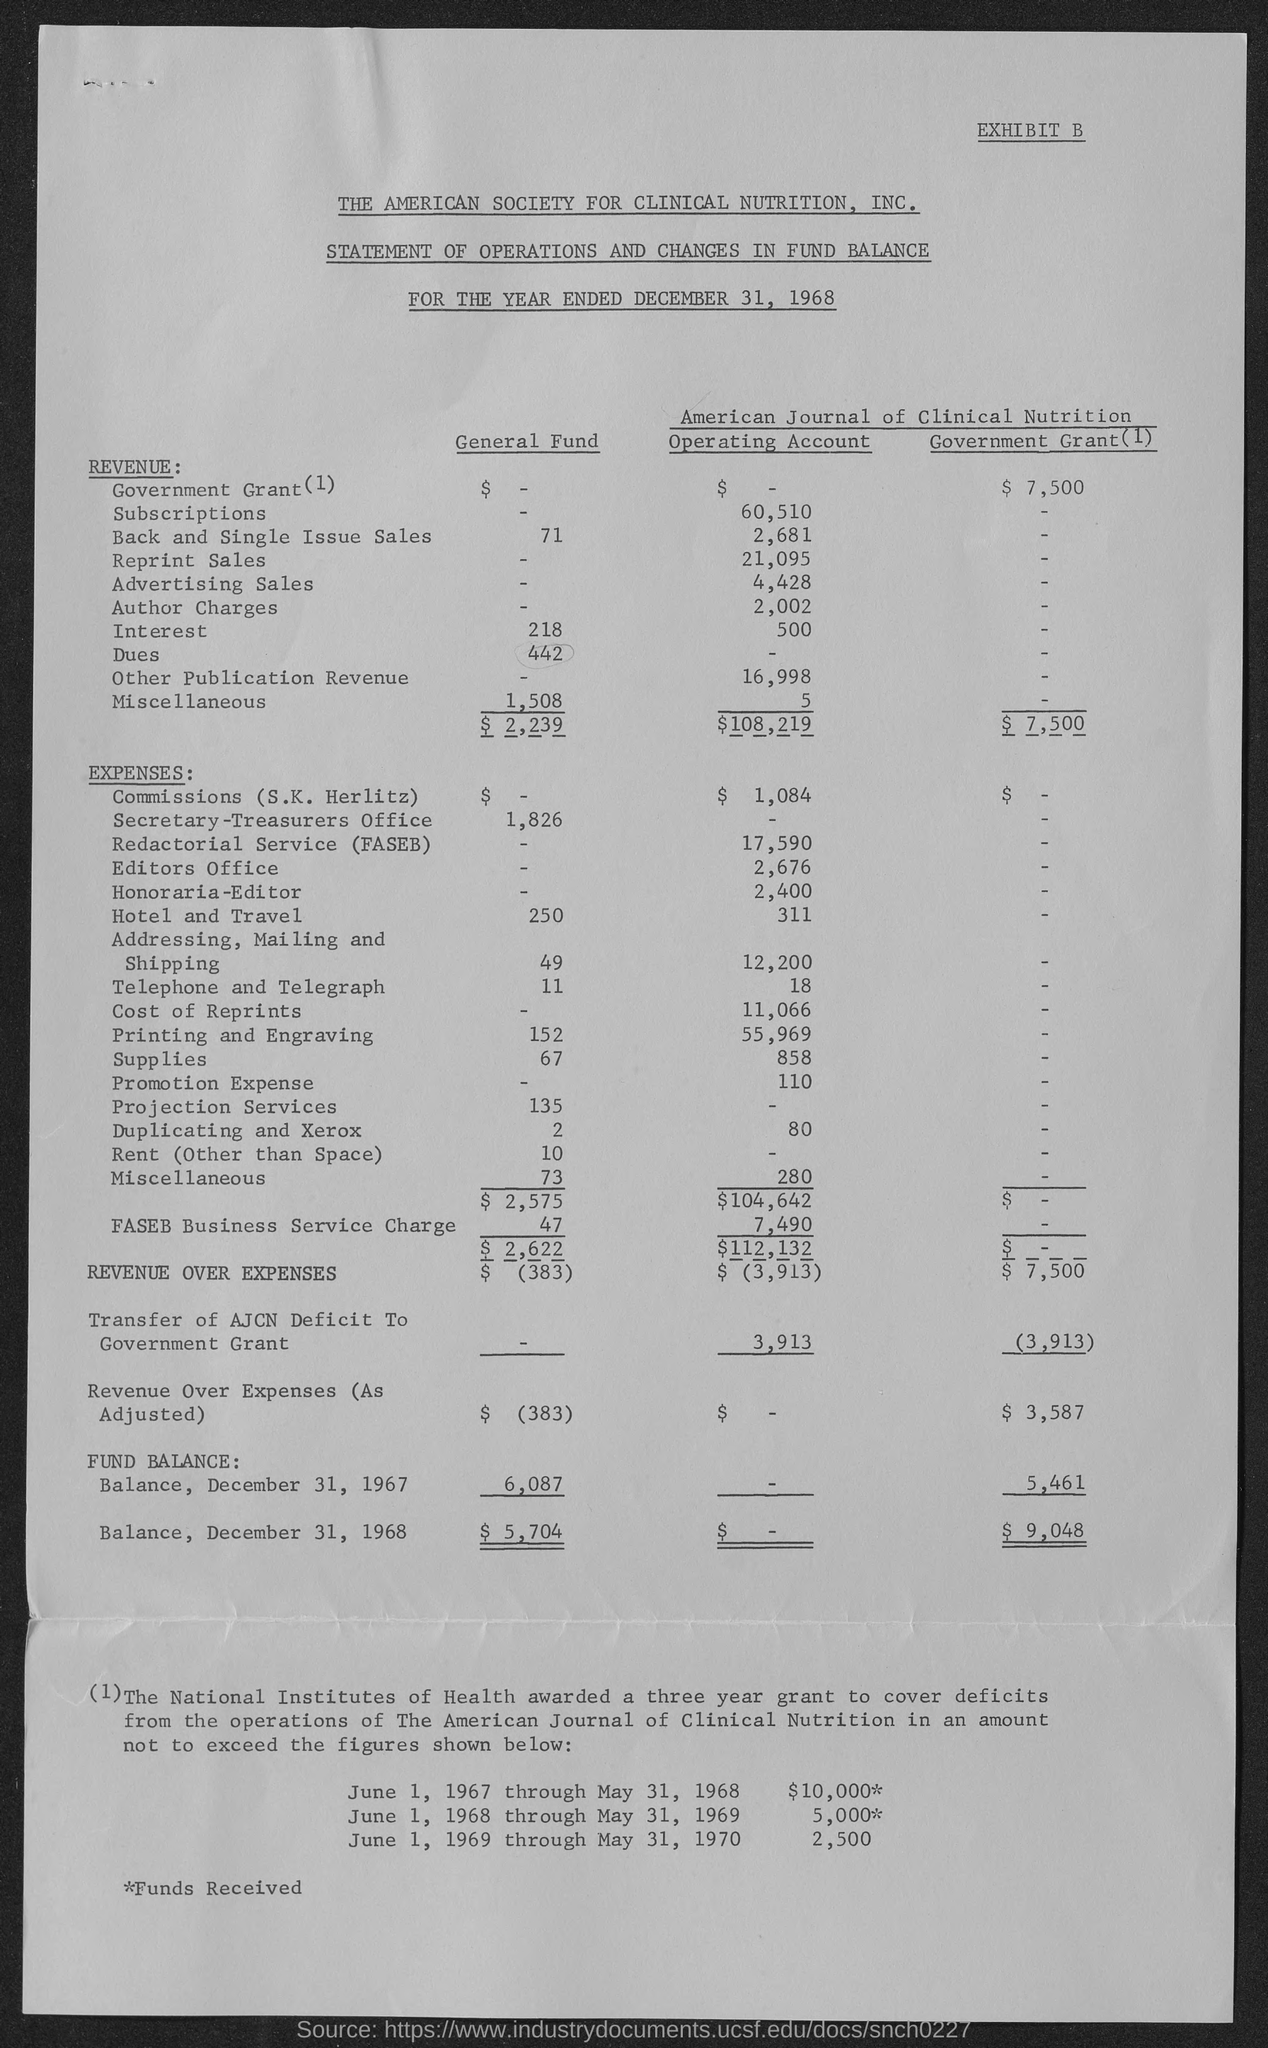Specify some key components in this picture. The total revenue generated from the General Fund was $2,239. The total revenue from the government grant was $7,500. According to the latest available data, the revenue generated by the General Fund is currently exceeding its expenses by 383. The total revenue from the Operating Account is $108,219. The revenue over expenses in the Operating Account is $3,913. 